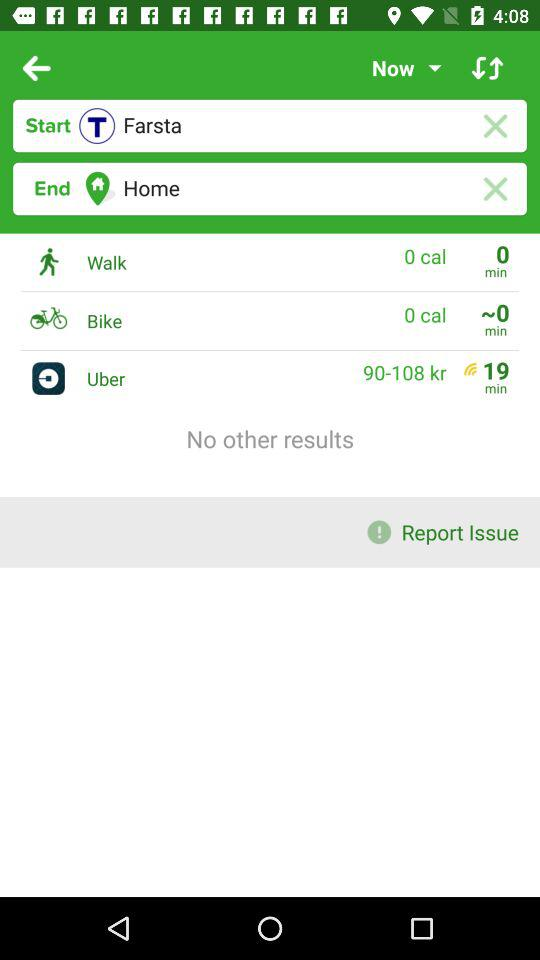How much time will it take for Uber? It will take 19 minutes. 